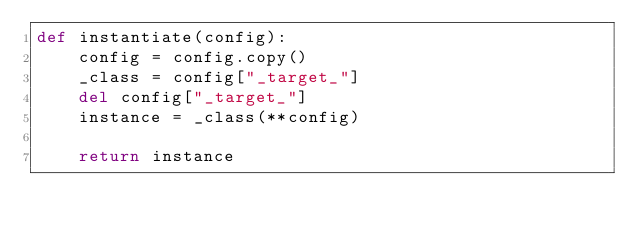<code> <loc_0><loc_0><loc_500><loc_500><_Python_>def instantiate(config):
    config = config.copy()
    _class = config["_target_"]
    del config["_target_"]
    instance = _class(**config)

    return instance
</code> 